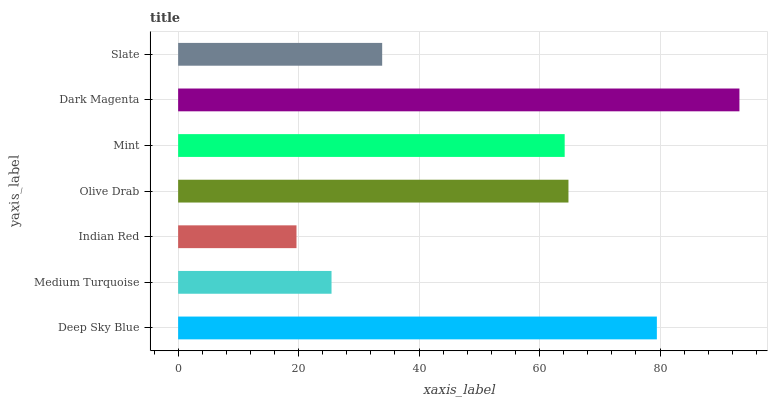Is Indian Red the minimum?
Answer yes or no. Yes. Is Dark Magenta the maximum?
Answer yes or no. Yes. Is Medium Turquoise the minimum?
Answer yes or no. No. Is Medium Turquoise the maximum?
Answer yes or no. No. Is Deep Sky Blue greater than Medium Turquoise?
Answer yes or no. Yes. Is Medium Turquoise less than Deep Sky Blue?
Answer yes or no. Yes. Is Medium Turquoise greater than Deep Sky Blue?
Answer yes or no. No. Is Deep Sky Blue less than Medium Turquoise?
Answer yes or no. No. Is Mint the high median?
Answer yes or no. Yes. Is Mint the low median?
Answer yes or no. Yes. Is Medium Turquoise the high median?
Answer yes or no. No. Is Olive Drab the low median?
Answer yes or no. No. 